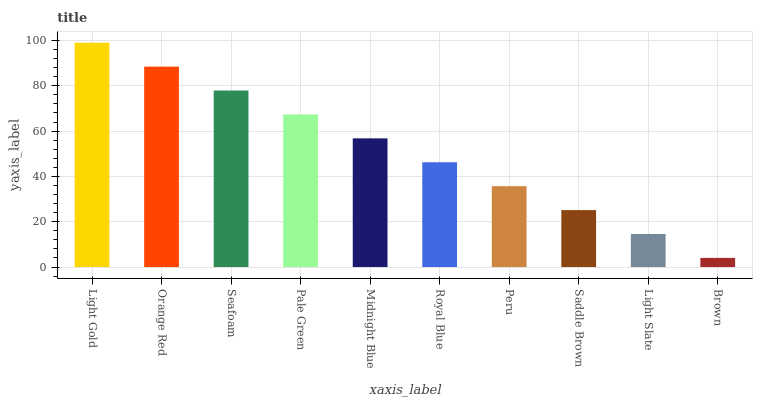Is Brown the minimum?
Answer yes or no. Yes. Is Light Gold the maximum?
Answer yes or no. Yes. Is Orange Red the minimum?
Answer yes or no. No. Is Orange Red the maximum?
Answer yes or no. No. Is Light Gold greater than Orange Red?
Answer yes or no. Yes. Is Orange Red less than Light Gold?
Answer yes or no. Yes. Is Orange Red greater than Light Gold?
Answer yes or no. No. Is Light Gold less than Orange Red?
Answer yes or no. No. Is Midnight Blue the high median?
Answer yes or no. Yes. Is Royal Blue the low median?
Answer yes or no. Yes. Is Orange Red the high median?
Answer yes or no. No. Is Light Slate the low median?
Answer yes or no. No. 